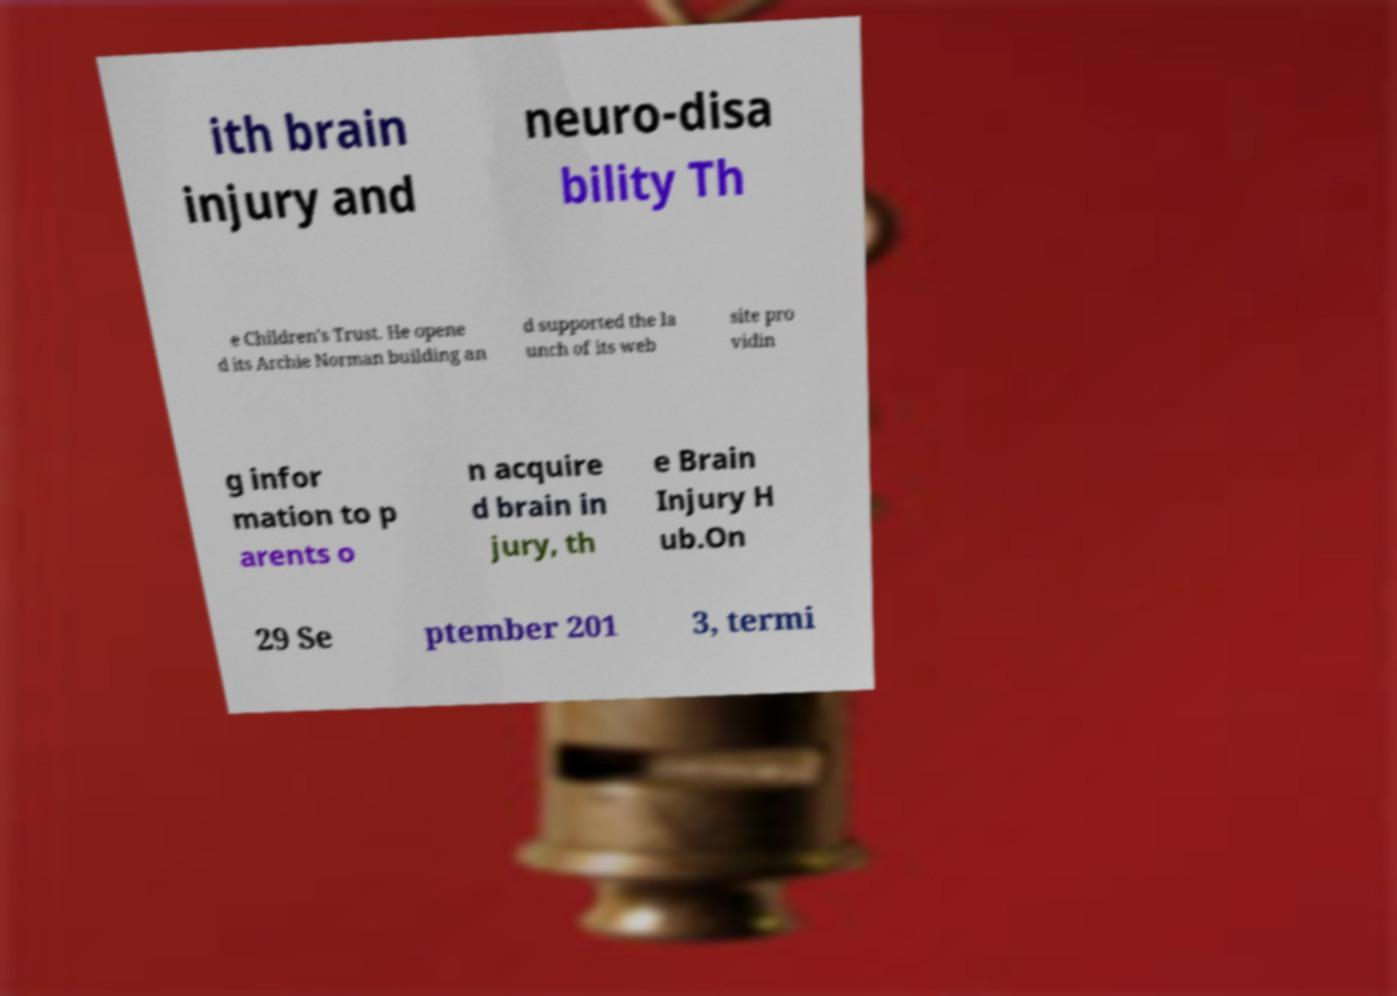Can you accurately transcribe the text from the provided image for me? ith brain injury and neuro-disa bility Th e Children's Trust. He opene d its Archie Norman building an d supported the la unch of its web site pro vidin g infor mation to p arents o n acquire d brain in jury, th e Brain Injury H ub.On 29 Se ptember 201 3, termi 